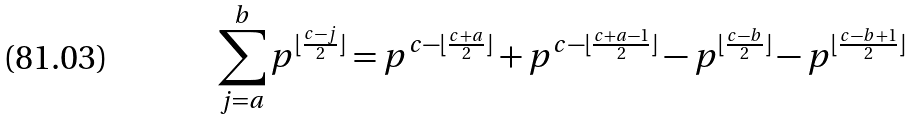Convert formula to latex. <formula><loc_0><loc_0><loc_500><loc_500>\sum _ { j = a } ^ { b } p ^ { \lfloor \frac { c - j } { 2 } \rfloor } = p ^ { c - \lfloor \frac { c + a } { 2 } \rfloor } + p ^ { c - \lfloor \frac { c + a - 1 } { 2 } \rfloor } - p ^ { \lfloor \frac { c - b } { 2 } \rfloor } - p ^ { \lfloor \frac { c - b + 1 } { 2 } \rfloor }</formula> 